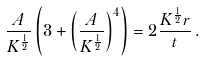<formula> <loc_0><loc_0><loc_500><loc_500>\frac { A } { K ^ { \frac { 1 } { 2 } } } \left ( 3 + \left ( \frac { A } { K ^ { \frac { 1 } { 2 } } } \right ) ^ { 4 } \right ) = 2 \frac { K ^ { \frac { 1 } { 2 } } r } { t } \, .</formula> 